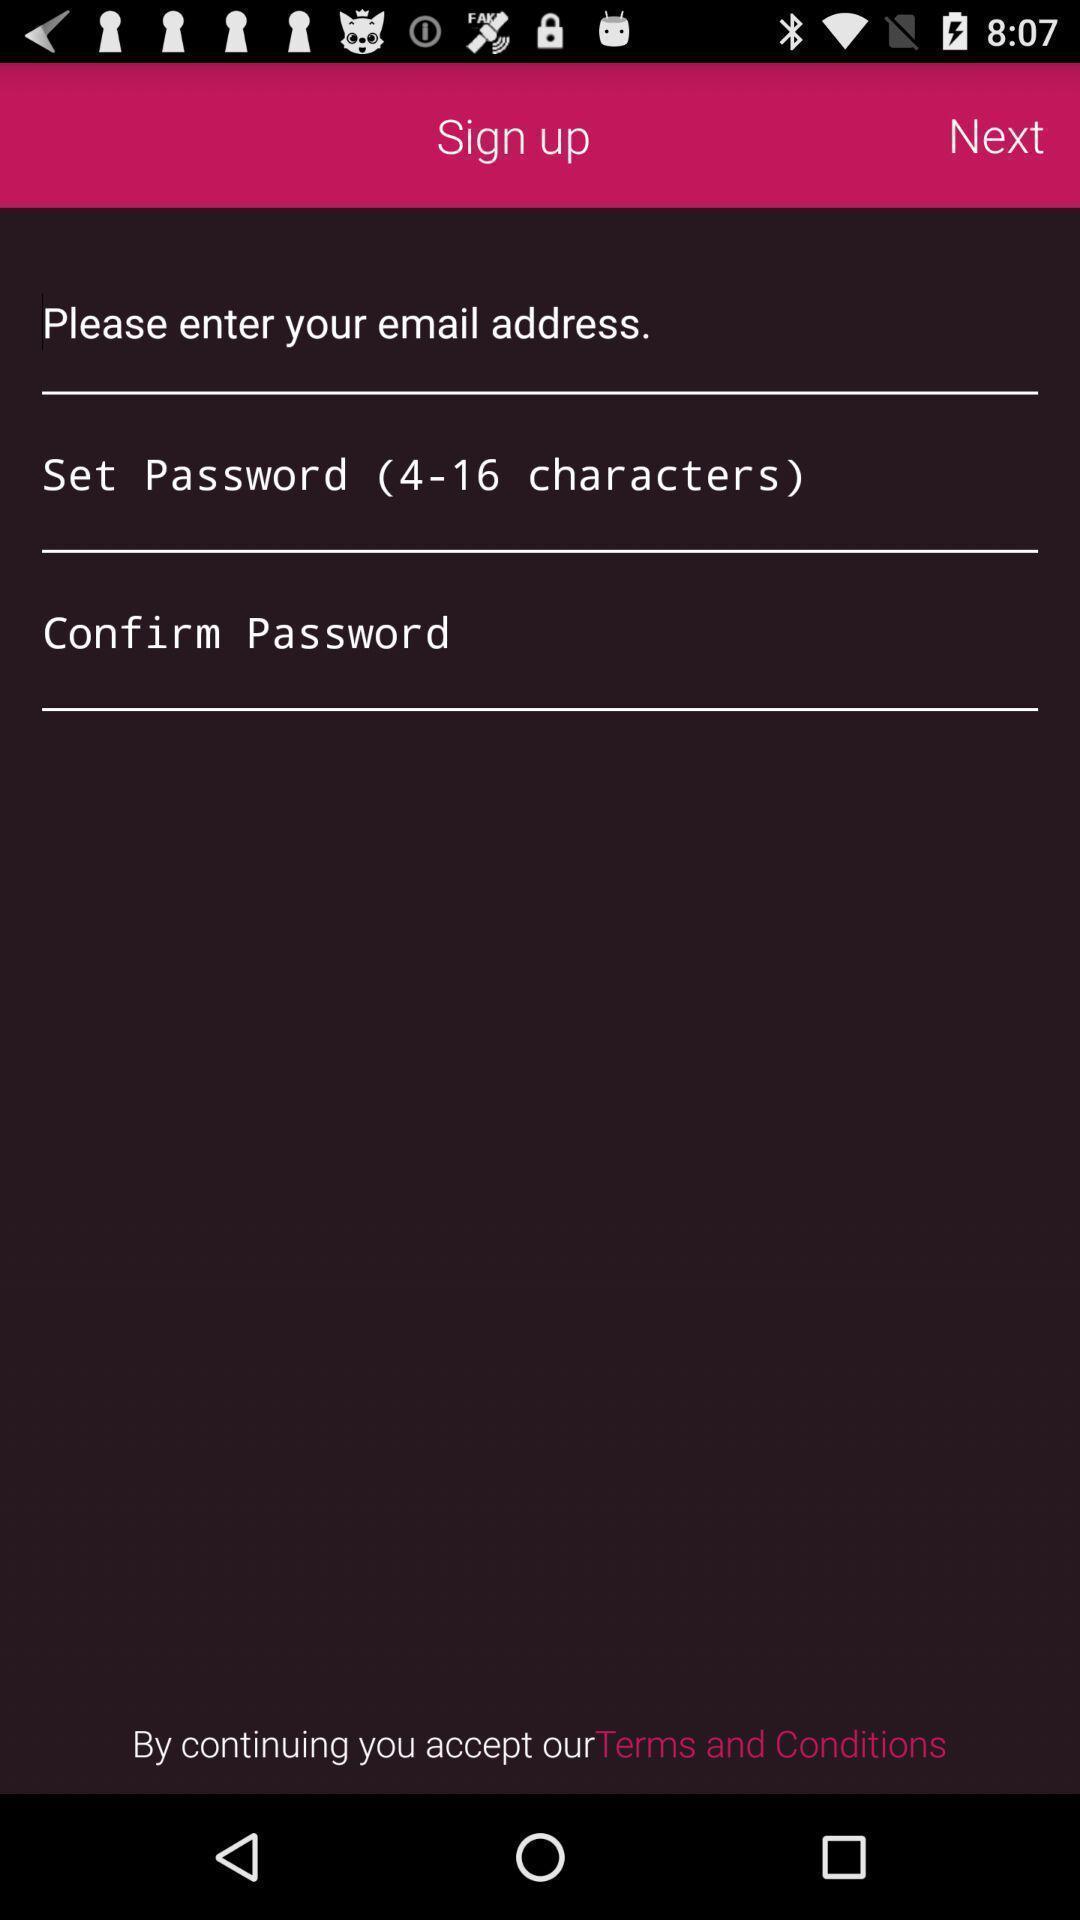Describe the visual elements of this screenshot. Signup page for accessing account. 